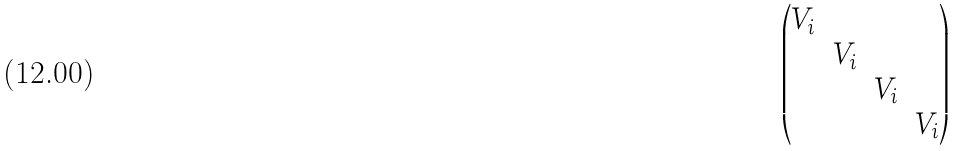Convert formula to latex. <formula><loc_0><loc_0><loc_500><loc_500>\begin{pmatrix} V _ { i } & & & \\ & V _ { i } & & \\ & & V _ { i } & \\ & & & V _ { i } \end{pmatrix}</formula> 